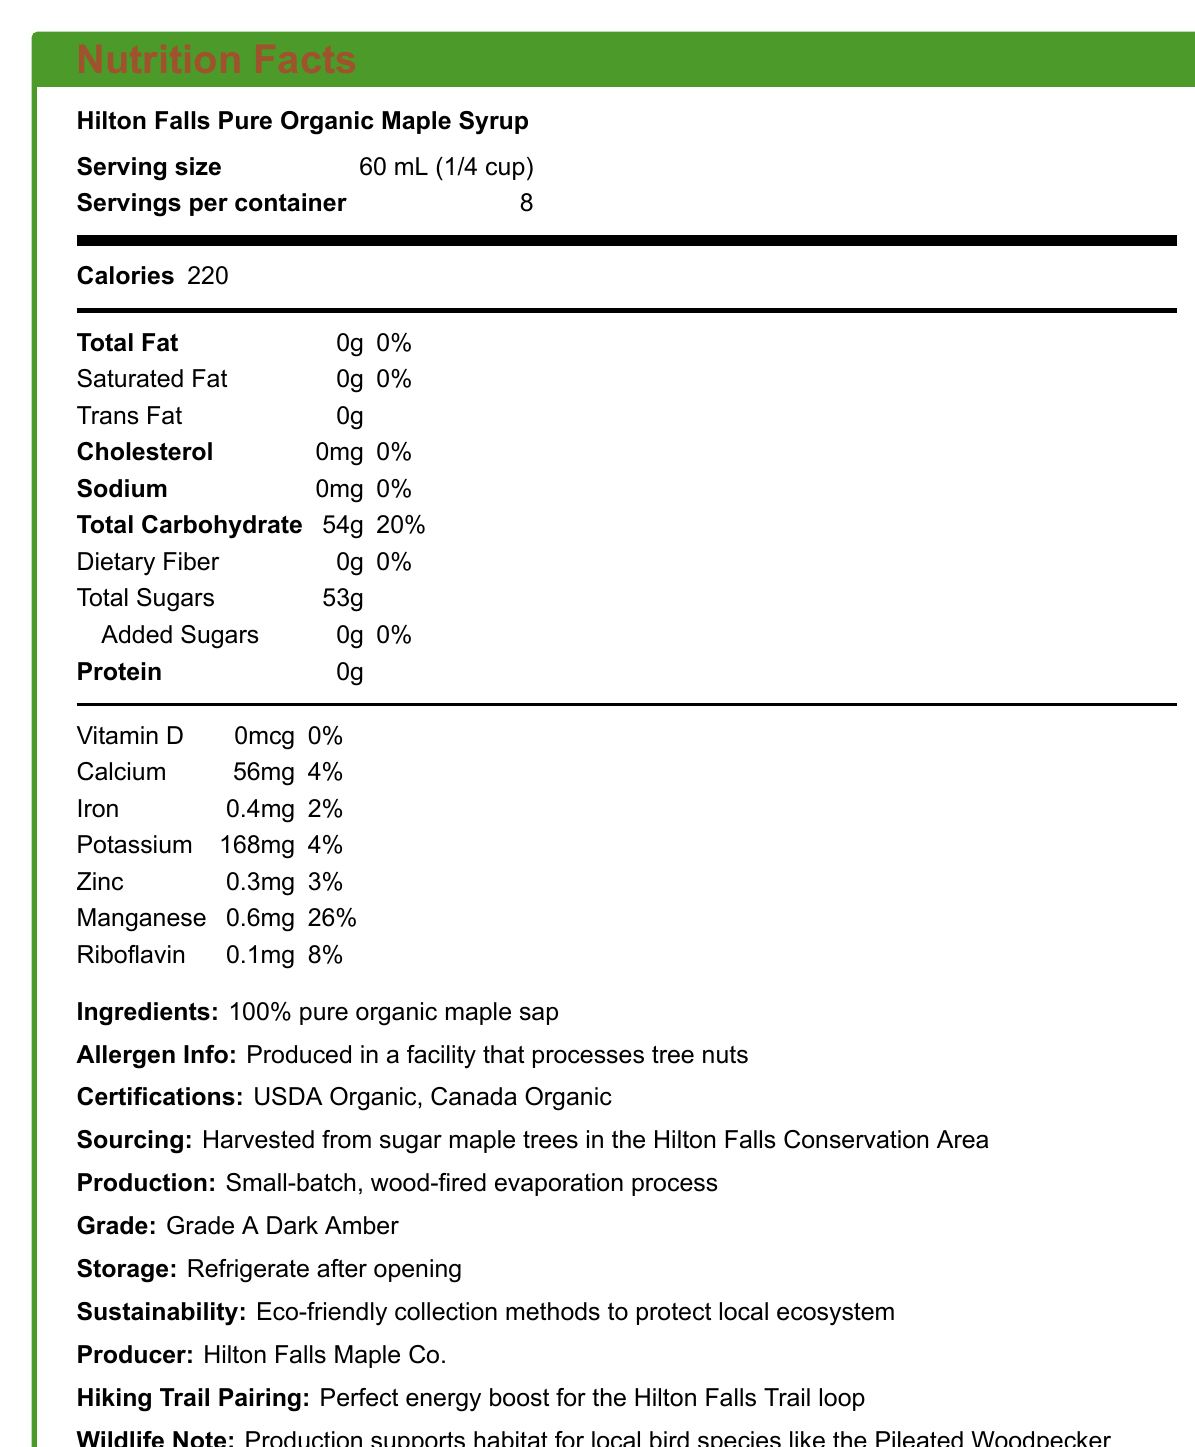what is the serving size? The serving size is listed as 60 mL (1/4 cup) in the document.
Answer: 60 mL (1/4 cup) how many servings are in each container? The document mentions that there are 8 servings per container.
Answer: 8 how many calories are there per serving? The document shows that there are 220 calories in a single serving.
Answer: 220 what is the total carbohydrate content per serving? The total carbohydrate content is indicated as 54g per serving.
Answer: 54g which vitamins and minerals are present in the syrup? The document lists these specific vitamins and minerals with their respective amounts.
Answer: Calcium, Iron, Potassium, Zinc, Manganese, Riboflavin what is the sodium content in this syrup? According to the document, the sodium content is 0mg per serving.
Answer: 0mg how much sugar is added to the syrup? The document states that there are no added sugars (0g).
Answer: 0g from where are the ingredients for the syrup sourced? The syrup is sourced from sugar maple trees in the Hilton Falls Conservation Area.
Answer: Hilton Falls Conservation Area what production method is used for this syrup? The document specifies that a small-batch, wood-fired evaporation process is used.
Answer: Small-batch, wood-fired evaporation process what storage instructions are given for the syrup? The document advises to refrigerate the syrup after opening.
Answer: Refrigerate after opening how many grams of protein are there per serving? The document indicates that there are 0g of protein per serving.
Answer: 0g which document section notes information about allergens? The allergen information is under the "Allergen Info" section.
Answer: Ingredients and Allergen Info what certification labels are mentioned for the syrup? The document lists USDA Organic and Canada Organic as certifications.
Answer: USDA Organic, Canada Organic what does the production of this syrup support in terms of wildlife? The document mentions that the production supports the habitat for local bird species including the Pileated Woodpecker.
Answer: Supports habitat for local bird species like the Pileated Woodpecker which of the following minerals has the highest percentage of daily value per serving? A. Calcium B. Iron C. Manganese D. Riboflavin Manganese has 26% of the daily value per serving, which is higher than Calcium (4%), Iron (2%), and Riboflavin (8%).
Answer: C. Manganese what is the carbohydrate source of this syrup? A. Added Sugars B. Dietary Fiber C. Pure Organic Maple Sap D. Artificial Sweeteners The only ingredient listed is 100% pure organic maple sap, indicating it is the source of carbohydrates.
Answer: C. Pure Organic Maple Sap Does this syrup contain any trans fat? The document indicates that the trans fat content is 0g.
Answer: No Is this product suitable for someone with nut allergies? The document states that the product is produced in a facility that processes tree nuts, which may pose a risk for someone with nut allergies.
Answer: No Summarize the main attributes of Hilton Falls Pure Organic Maple Syrup The summary encapsulates the product's certifications, sourcing, production method, nutritional content, storage instructions, and sustainability efforts.
Answer: The document details that Hilton Falls Pure Organic Maple Syrup is USDA Organic and Canada Organic certified, harvested from sugar maple trees in Hilton Falls Conservation Area, produced using a small-batch, wood-fired evaporation process, and is nutrient-rich with no added sugars. It contains no fat, cholesterol, or sodium, but is rich in carbohydrates and provides certain vitamins and minerals. Storage instructions advise refrigerating after opening, and the production supports local wildlife. is the packaging of the syrup biodegradable? The document does not provide any information about the packaging being biodegradable.
Answer: Not enough information 